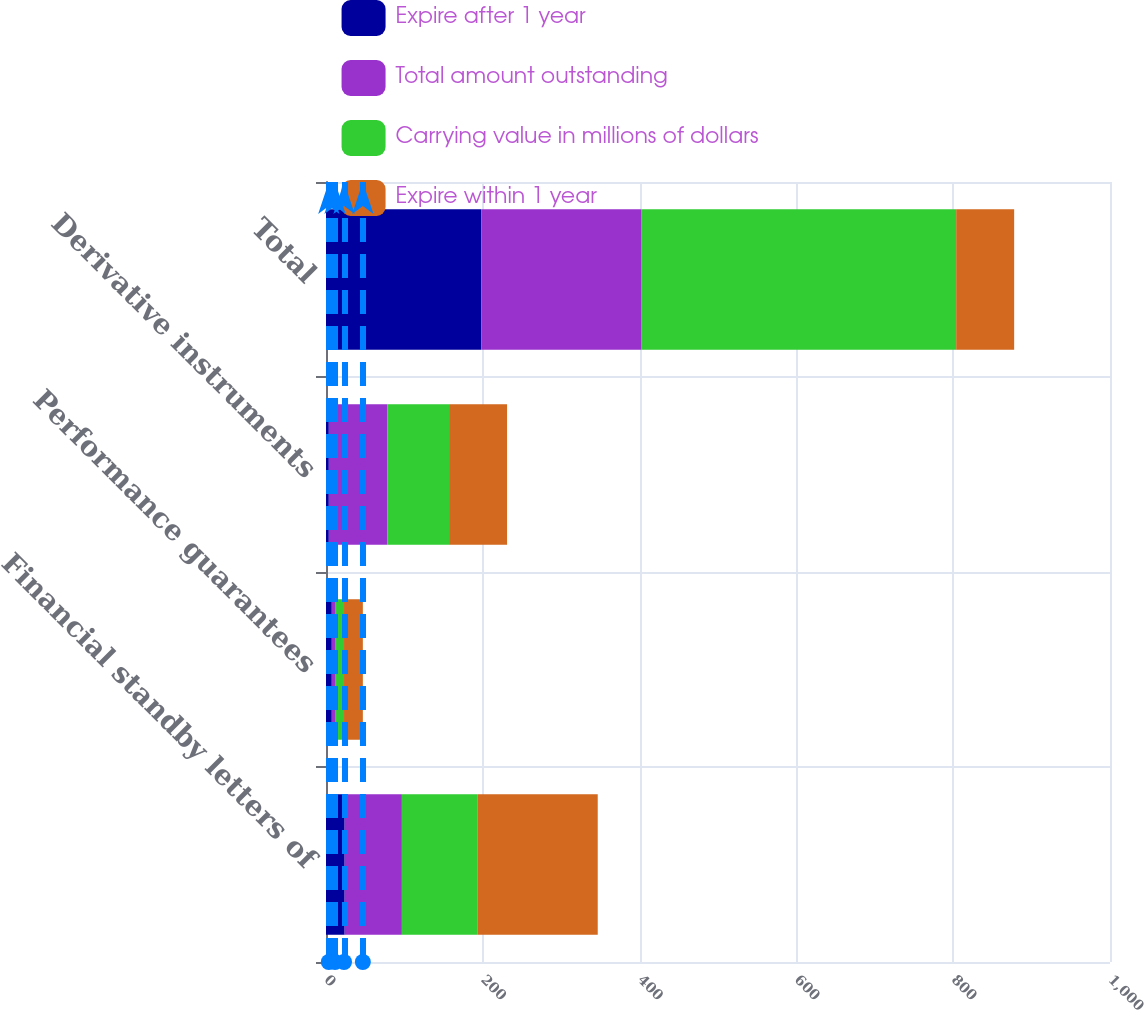Convert chart. <chart><loc_0><loc_0><loc_500><loc_500><stacked_bar_chart><ecel><fcel>Financial standby letters of<fcel>Performance guarantees<fcel>Derivative instruments<fcel>Total<nl><fcel>Expire after 1 year<fcel>23.8<fcel>7.4<fcel>3.6<fcel>198<nl><fcel>Total amount outstanding<fcel>73<fcel>4.1<fcel>74.9<fcel>203.9<nl><fcel>Carrying value in millions of dollars<fcel>96.8<fcel>11.5<fcel>78.5<fcel>401.9<nl><fcel>Expire within 1 year<fcel>153<fcel>24<fcel>73.95<fcel>73.95<nl></chart> 